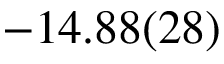Convert formula to latex. <formula><loc_0><loc_0><loc_500><loc_500>- 1 4 . 8 8 ( 2 8 )</formula> 